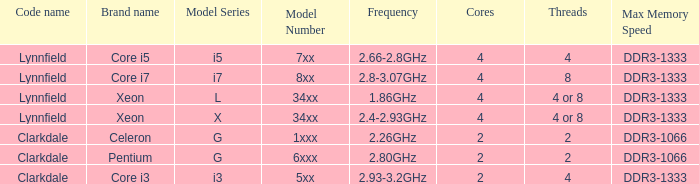What brand is model G6xxx? Pentium. 